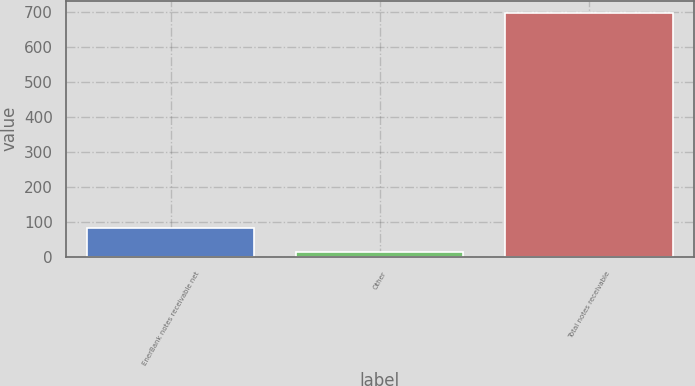<chart> <loc_0><loc_0><loc_500><loc_500><bar_chart><fcel>EnerBank notes receivable net<fcel>Other<fcel>Total notes receivable<nl><fcel>83.3<fcel>15<fcel>698<nl></chart> 